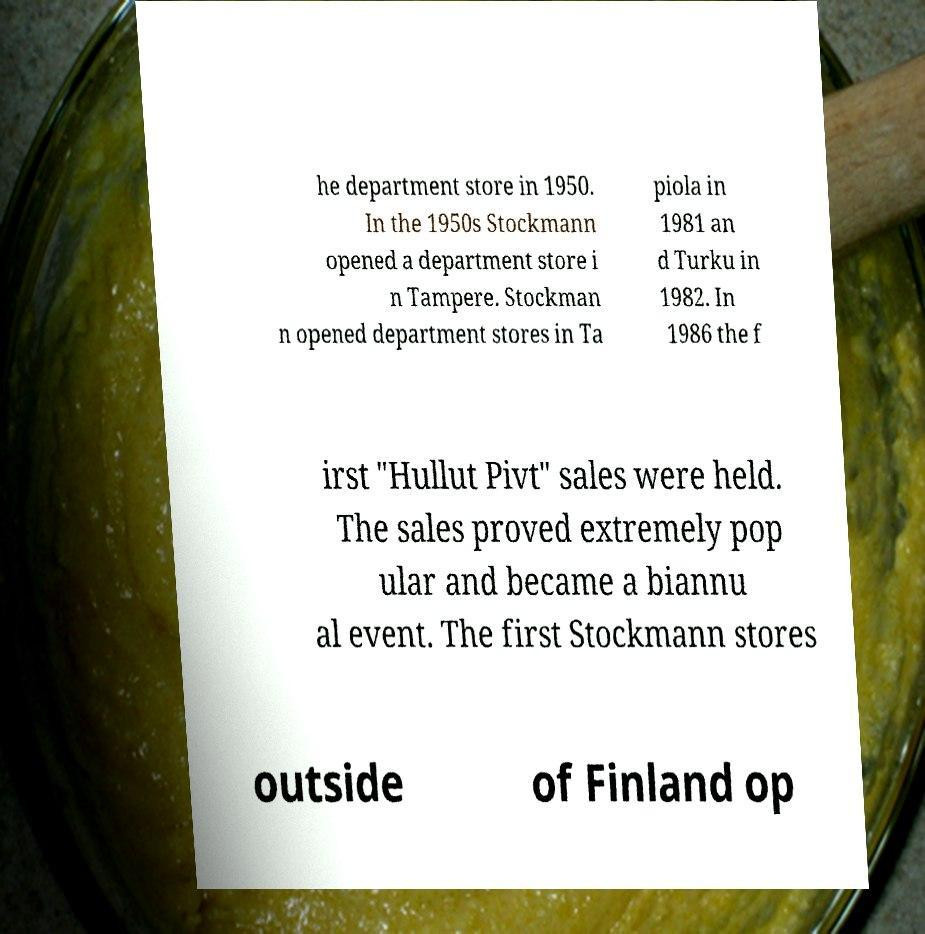What messages or text are displayed in this image? I need them in a readable, typed format. he department store in 1950. In the 1950s Stockmann opened a department store i n Tampere. Stockman n opened department stores in Ta piola in 1981 an d Turku in 1982. In 1986 the f irst "Hullut Pivt" sales were held. The sales proved extremely pop ular and became a biannu al event. The first Stockmann stores outside of Finland op 